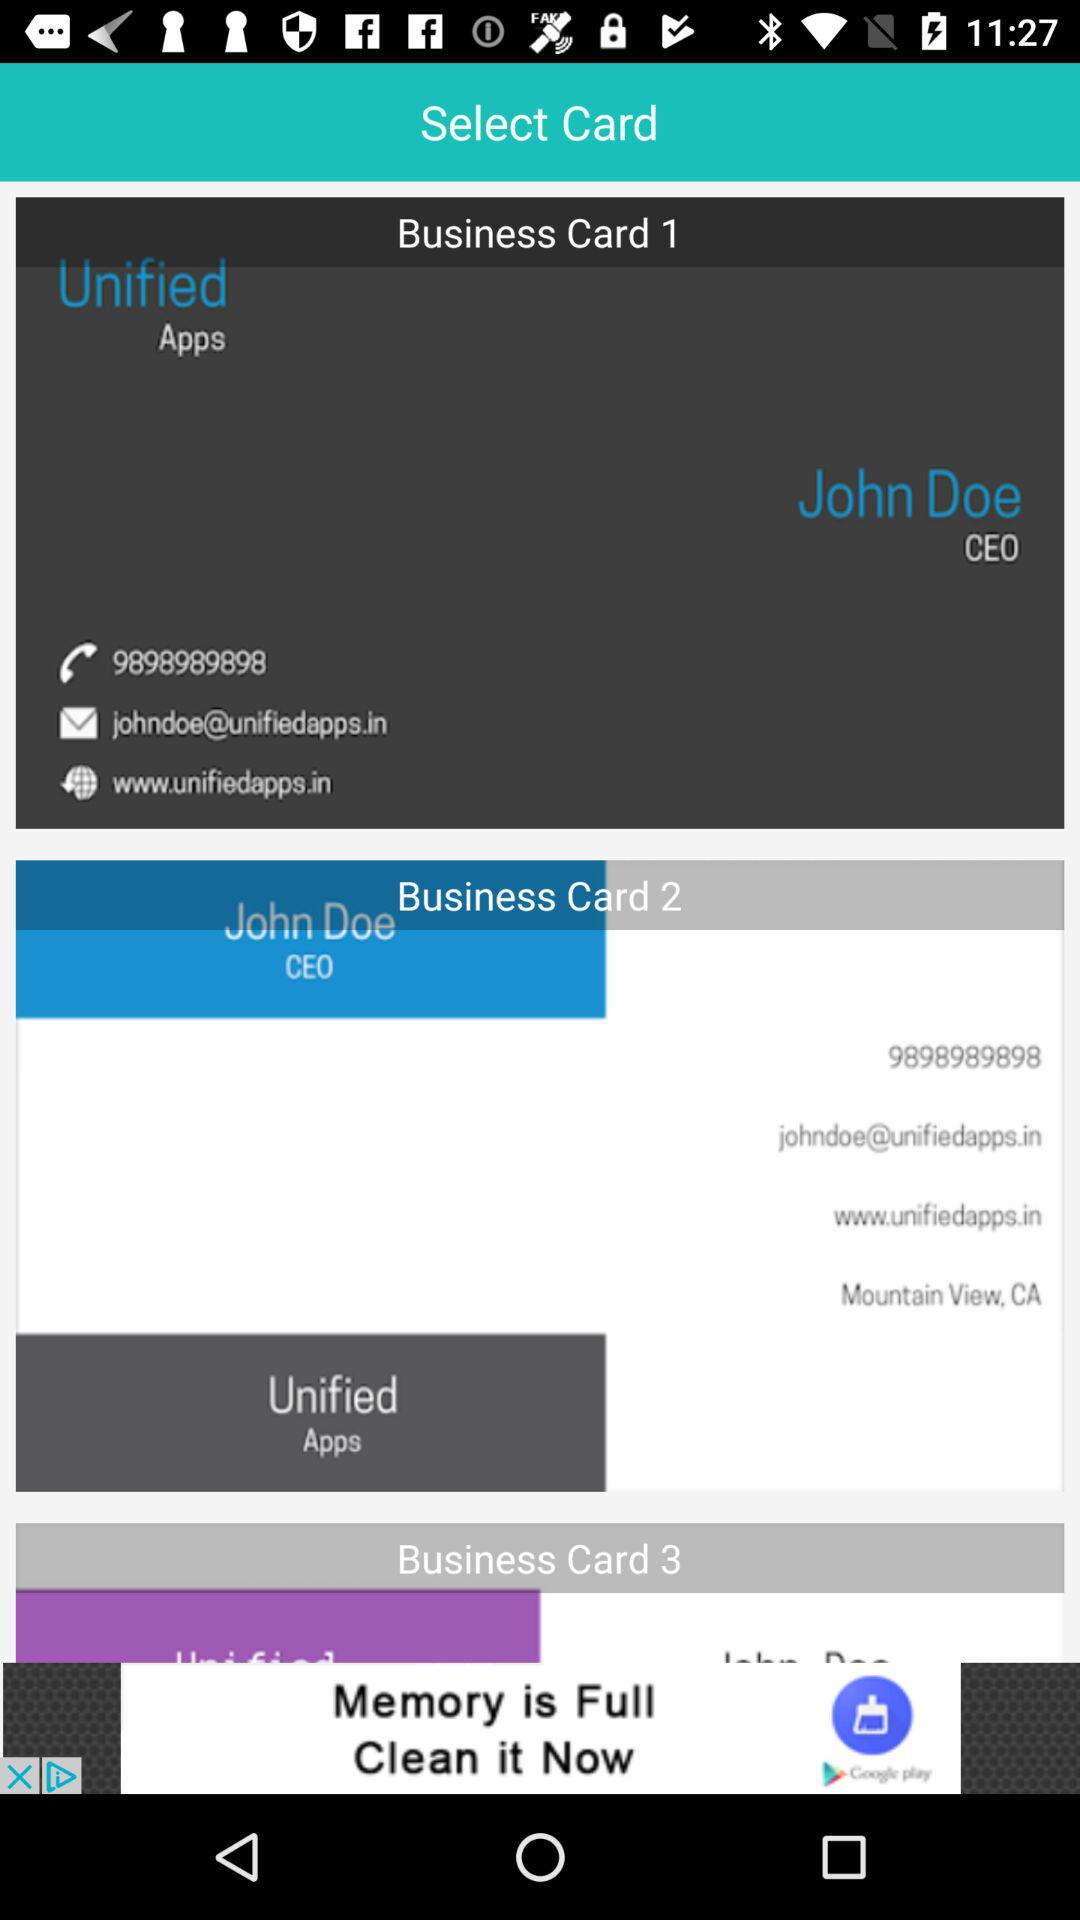What is the email address? The email address is johndoe@unifiedapps.in. 